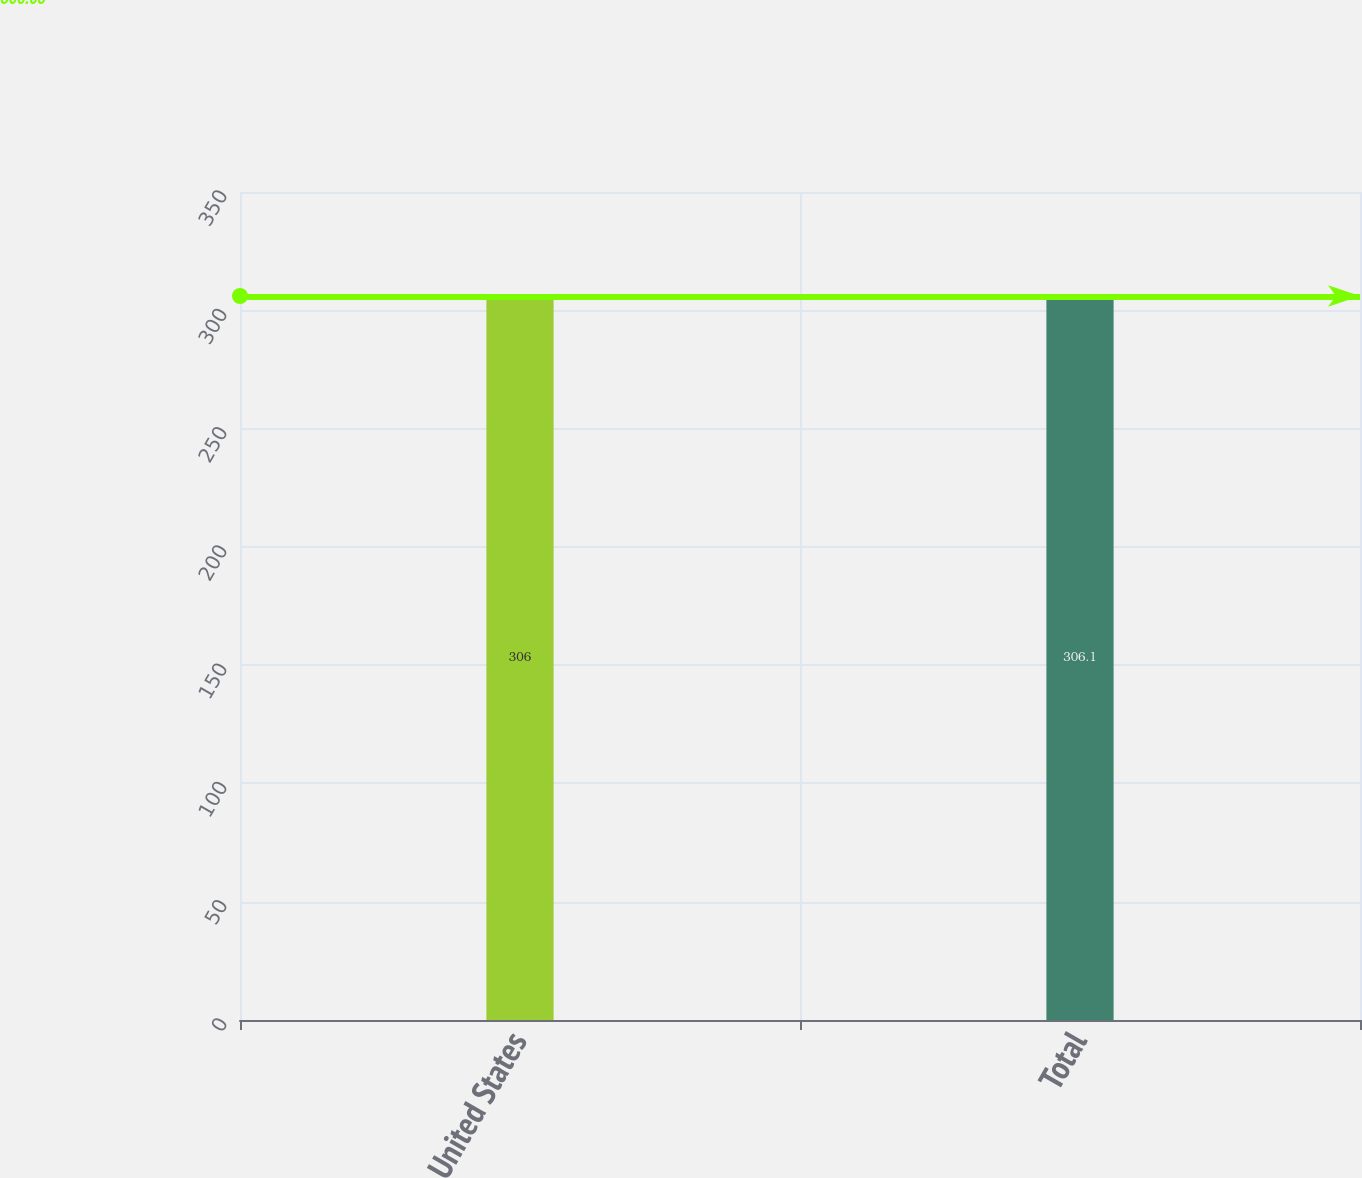Convert chart to OTSL. <chart><loc_0><loc_0><loc_500><loc_500><bar_chart><fcel>United States<fcel>Total<nl><fcel>306<fcel>306.1<nl></chart> 